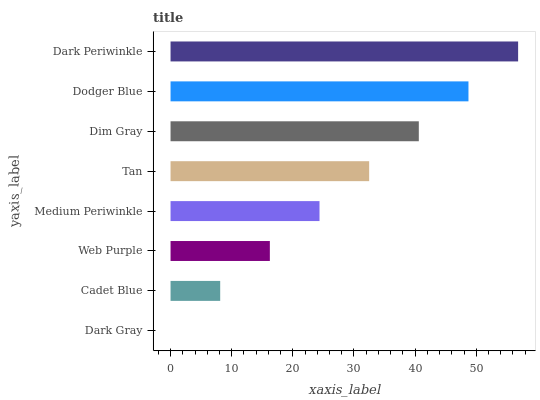Is Dark Gray the minimum?
Answer yes or no. Yes. Is Dark Periwinkle the maximum?
Answer yes or no. Yes. Is Cadet Blue the minimum?
Answer yes or no. No. Is Cadet Blue the maximum?
Answer yes or no. No. Is Cadet Blue greater than Dark Gray?
Answer yes or no. Yes. Is Dark Gray less than Cadet Blue?
Answer yes or no. Yes. Is Dark Gray greater than Cadet Blue?
Answer yes or no. No. Is Cadet Blue less than Dark Gray?
Answer yes or no. No. Is Tan the high median?
Answer yes or no. Yes. Is Medium Periwinkle the low median?
Answer yes or no. Yes. Is Cadet Blue the high median?
Answer yes or no. No. Is Web Purple the low median?
Answer yes or no. No. 